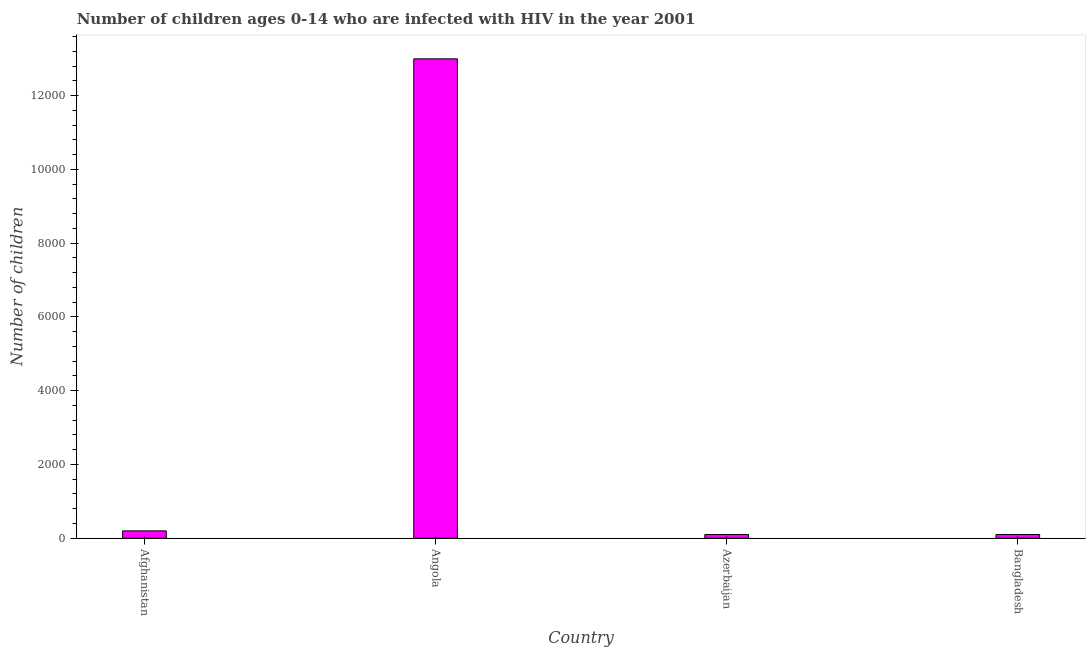Does the graph contain grids?
Keep it short and to the point. No. What is the title of the graph?
Keep it short and to the point. Number of children ages 0-14 who are infected with HIV in the year 2001. What is the label or title of the X-axis?
Offer a very short reply. Country. What is the label or title of the Y-axis?
Keep it short and to the point. Number of children. Across all countries, what is the maximum number of children living with hiv?
Offer a very short reply. 1.30e+04. In which country was the number of children living with hiv maximum?
Keep it short and to the point. Angola. In which country was the number of children living with hiv minimum?
Provide a succinct answer. Azerbaijan. What is the sum of the number of children living with hiv?
Your response must be concise. 1.34e+04. What is the difference between the number of children living with hiv in Afghanistan and Azerbaijan?
Offer a terse response. 100. What is the average number of children living with hiv per country?
Give a very brief answer. 3350. What is the median number of children living with hiv?
Ensure brevity in your answer.  150. What is the ratio of the number of children living with hiv in Afghanistan to that in Angola?
Keep it short and to the point. 0.01. Is the number of children living with hiv in Afghanistan less than that in Bangladesh?
Give a very brief answer. No. What is the difference between the highest and the second highest number of children living with hiv?
Ensure brevity in your answer.  1.28e+04. What is the difference between the highest and the lowest number of children living with hiv?
Make the answer very short. 1.29e+04. How many countries are there in the graph?
Your response must be concise. 4. Are the values on the major ticks of Y-axis written in scientific E-notation?
Keep it short and to the point. No. What is the Number of children of Angola?
Ensure brevity in your answer.  1.30e+04. What is the Number of children of Azerbaijan?
Offer a terse response. 100. What is the Number of children of Bangladesh?
Give a very brief answer. 100. What is the difference between the Number of children in Afghanistan and Angola?
Make the answer very short. -1.28e+04. What is the difference between the Number of children in Afghanistan and Azerbaijan?
Provide a succinct answer. 100. What is the difference between the Number of children in Afghanistan and Bangladesh?
Make the answer very short. 100. What is the difference between the Number of children in Angola and Azerbaijan?
Provide a succinct answer. 1.29e+04. What is the difference between the Number of children in Angola and Bangladesh?
Offer a terse response. 1.29e+04. What is the difference between the Number of children in Azerbaijan and Bangladesh?
Make the answer very short. 0. What is the ratio of the Number of children in Afghanistan to that in Angola?
Provide a succinct answer. 0.01. What is the ratio of the Number of children in Afghanistan to that in Azerbaijan?
Make the answer very short. 2. What is the ratio of the Number of children in Afghanistan to that in Bangladesh?
Provide a succinct answer. 2. What is the ratio of the Number of children in Angola to that in Azerbaijan?
Give a very brief answer. 130. What is the ratio of the Number of children in Angola to that in Bangladesh?
Provide a succinct answer. 130. What is the ratio of the Number of children in Azerbaijan to that in Bangladesh?
Make the answer very short. 1. 